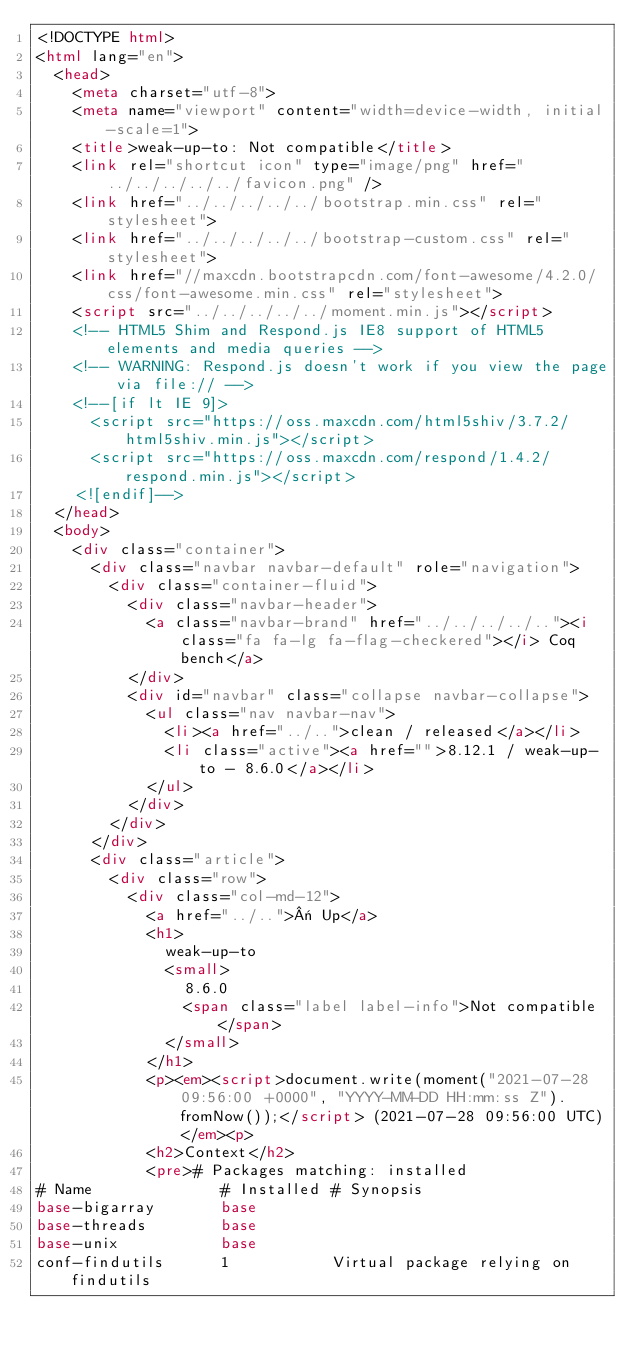<code> <loc_0><loc_0><loc_500><loc_500><_HTML_><!DOCTYPE html>
<html lang="en">
  <head>
    <meta charset="utf-8">
    <meta name="viewport" content="width=device-width, initial-scale=1">
    <title>weak-up-to: Not compatible</title>
    <link rel="shortcut icon" type="image/png" href="../../../../../favicon.png" />
    <link href="../../../../../bootstrap.min.css" rel="stylesheet">
    <link href="../../../../../bootstrap-custom.css" rel="stylesheet">
    <link href="//maxcdn.bootstrapcdn.com/font-awesome/4.2.0/css/font-awesome.min.css" rel="stylesheet">
    <script src="../../../../../moment.min.js"></script>
    <!-- HTML5 Shim and Respond.js IE8 support of HTML5 elements and media queries -->
    <!-- WARNING: Respond.js doesn't work if you view the page via file:// -->
    <!--[if lt IE 9]>
      <script src="https://oss.maxcdn.com/html5shiv/3.7.2/html5shiv.min.js"></script>
      <script src="https://oss.maxcdn.com/respond/1.4.2/respond.min.js"></script>
    <![endif]-->
  </head>
  <body>
    <div class="container">
      <div class="navbar navbar-default" role="navigation">
        <div class="container-fluid">
          <div class="navbar-header">
            <a class="navbar-brand" href="../../../../.."><i class="fa fa-lg fa-flag-checkered"></i> Coq bench</a>
          </div>
          <div id="navbar" class="collapse navbar-collapse">
            <ul class="nav navbar-nav">
              <li><a href="../..">clean / released</a></li>
              <li class="active"><a href="">8.12.1 / weak-up-to - 8.6.0</a></li>
            </ul>
          </div>
        </div>
      </div>
      <div class="article">
        <div class="row">
          <div class="col-md-12">
            <a href="../..">« Up</a>
            <h1>
              weak-up-to
              <small>
                8.6.0
                <span class="label label-info">Not compatible</span>
              </small>
            </h1>
            <p><em><script>document.write(moment("2021-07-28 09:56:00 +0000", "YYYY-MM-DD HH:mm:ss Z").fromNow());</script> (2021-07-28 09:56:00 UTC)</em><p>
            <h2>Context</h2>
            <pre># Packages matching: installed
# Name              # Installed # Synopsis
base-bigarray       base
base-threads        base
base-unix           base
conf-findutils      1           Virtual package relying on findutils</code> 